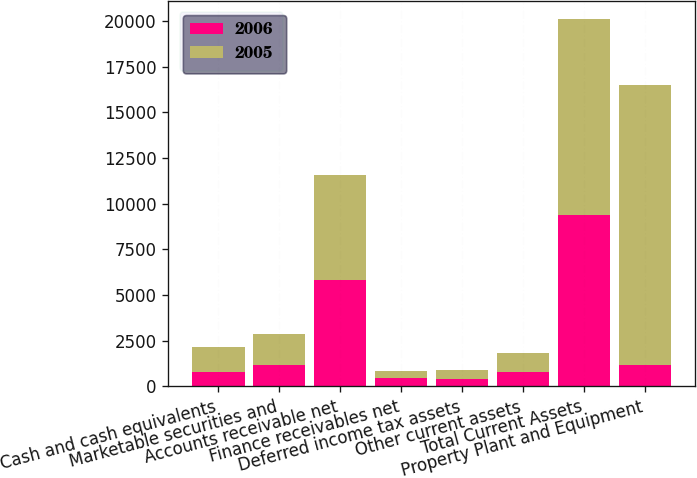Convert chart. <chart><loc_0><loc_0><loc_500><loc_500><stacked_bar_chart><ecel><fcel>Cash and cash equivalents<fcel>Marketable securities and<fcel>Accounts receivable net<fcel>Finance receivables net<fcel>Deferred income tax assets<fcel>Other current assets<fcel>Total Current Assets<fcel>Property Plant and Equipment<nl><fcel>2006<fcel>794<fcel>1189<fcel>5794<fcel>426<fcel>414<fcel>760<fcel>9377<fcel>1189<nl><fcel>2005<fcel>1369<fcel>1672<fcel>5743<fcel>411<fcel>475<fcel>1058<fcel>10728<fcel>15289<nl></chart> 